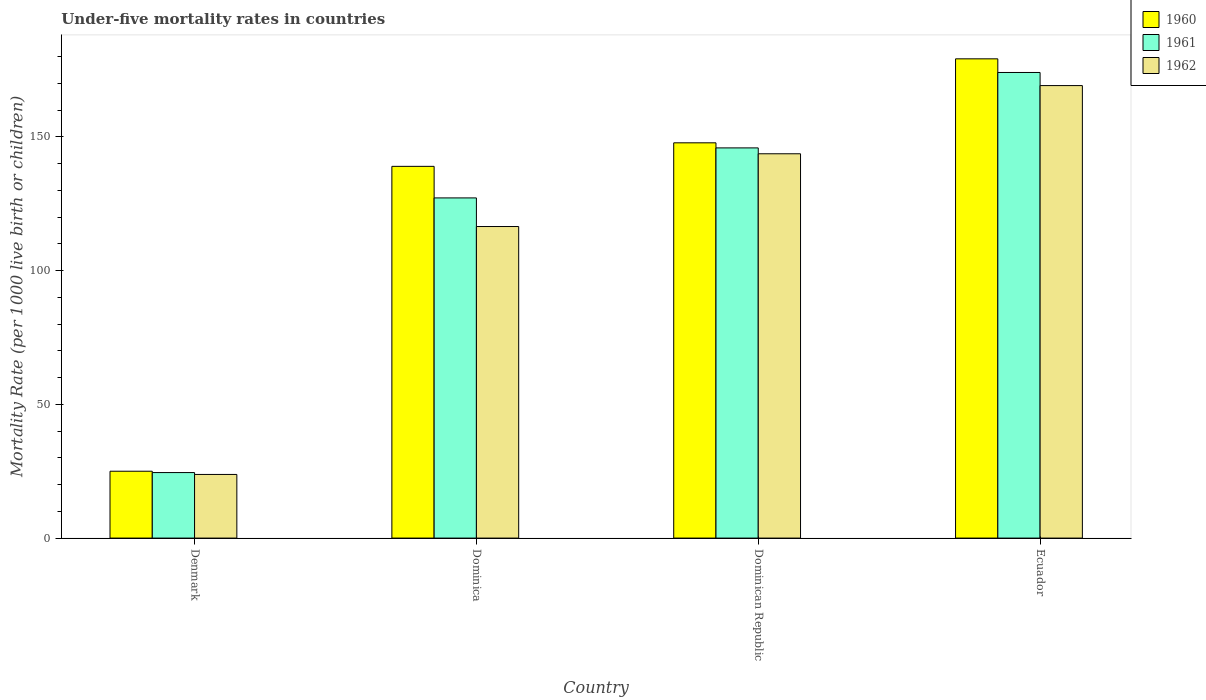How many different coloured bars are there?
Make the answer very short. 3. How many groups of bars are there?
Ensure brevity in your answer.  4. Are the number of bars per tick equal to the number of legend labels?
Your answer should be compact. Yes. Are the number of bars on each tick of the X-axis equal?
Your response must be concise. Yes. How many bars are there on the 3rd tick from the right?
Keep it short and to the point. 3. What is the label of the 1st group of bars from the left?
Offer a terse response. Denmark. What is the under-five mortality rate in 1962 in Dominica?
Keep it short and to the point. 116.5. Across all countries, what is the maximum under-five mortality rate in 1960?
Your answer should be compact. 179.2. Across all countries, what is the minimum under-five mortality rate in 1962?
Provide a short and direct response. 23.8. In which country was the under-five mortality rate in 1961 maximum?
Make the answer very short. Ecuador. What is the total under-five mortality rate in 1961 in the graph?
Offer a terse response. 471.7. What is the difference between the under-five mortality rate in 1961 in Dominica and that in Dominican Republic?
Make the answer very short. -18.7. What is the difference between the under-five mortality rate in 1962 in Denmark and the under-five mortality rate in 1960 in Dominica?
Provide a succinct answer. -115.2. What is the average under-five mortality rate in 1960 per country?
Give a very brief answer. 122.75. What is the difference between the under-five mortality rate of/in 1962 and under-five mortality rate of/in 1960 in Denmark?
Give a very brief answer. -1.2. What is the ratio of the under-five mortality rate in 1961 in Denmark to that in Ecuador?
Your answer should be compact. 0.14. Is the under-five mortality rate in 1960 in Dominica less than that in Ecuador?
Offer a terse response. Yes. Is the difference between the under-five mortality rate in 1962 in Denmark and Dominica greater than the difference between the under-five mortality rate in 1960 in Denmark and Dominica?
Ensure brevity in your answer.  Yes. What is the difference between the highest and the second highest under-five mortality rate in 1961?
Your response must be concise. -28.2. What is the difference between the highest and the lowest under-five mortality rate in 1960?
Your response must be concise. 154.2. In how many countries, is the under-five mortality rate in 1962 greater than the average under-five mortality rate in 1962 taken over all countries?
Your response must be concise. 3. What does the 3rd bar from the right in Dominican Republic represents?
Your response must be concise. 1960. Are all the bars in the graph horizontal?
Offer a terse response. No. How many countries are there in the graph?
Your response must be concise. 4. Are the values on the major ticks of Y-axis written in scientific E-notation?
Offer a terse response. No. Does the graph contain any zero values?
Ensure brevity in your answer.  No. Where does the legend appear in the graph?
Offer a very short reply. Top right. How many legend labels are there?
Ensure brevity in your answer.  3. How are the legend labels stacked?
Your answer should be compact. Vertical. What is the title of the graph?
Make the answer very short. Under-five mortality rates in countries. Does "1970" appear as one of the legend labels in the graph?
Keep it short and to the point. No. What is the label or title of the X-axis?
Offer a very short reply. Country. What is the label or title of the Y-axis?
Make the answer very short. Mortality Rate (per 1000 live birth or children). What is the Mortality Rate (per 1000 live birth or children) in 1961 in Denmark?
Your answer should be compact. 24.5. What is the Mortality Rate (per 1000 live birth or children) in 1962 in Denmark?
Your answer should be very brief. 23.8. What is the Mortality Rate (per 1000 live birth or children) in 1960 in Dominica?
Provide a short and direct response. 139. What is the Mortality Rate (per 1000 live birth or children) in 1961 in Dominica?
Your answer should be very brief. 127.2. What is the Mortality Rate (per 1000 live birth or children) of 1962 in Dominica?
Your answer should be compact. 116.5. What is the Mortality Rate (per 1000 live birth or children) in 1960 in Dominican Republic?
Your answer should be compact. 147.8. What is the Mortality Rate (per 1000 live birth or children) of 1961 in Dominican Republic?
Ensure brevity in your answer.  145.9. What is the Mortality Rate (per 1000 live birth or children) of 1962 in Dominican Republic?
Your answer should be very brief. 143.7. What is the Mortality Rate (per 1000 live birth or children) in 1960 in Ecuador?
Your answer should be very brief. 179.2. What is the Mortality Rate (per 1000 live birth or children) of 1961 in Ecuador?
Provide a succinct answer. 174.1. What is the Mortality Rate (per 1000 live birth or children) of 1962 in Ecuador?
Keep it short and to the point. 169.2. Across all countries, what is the maximum Mortality Rate (per 1000 live birth or children) of 1960?
Provide a short and direct response. 179.2. Across all countries, what is the maximum Mortality Rate (per 1000 live birth or children) of 1961?
Provide a succinct answer. 174.1. Across all countries, what is the maximum Mortality Rate (per 1000 live birth or children) in 1962?
Keep it short and to the point. 169.2. Across all countries, what is the minimum Mortality Rate (per 1000 live birth or children) of 1961?
Offer a terse response. 24.5. Across all countries, what is the minimum Mortality Rate (per 1000 live birth or children) in 1962?
Offer a very short reply. 23.8. What is the total Mortality Rate (per 1000 live birth or children) in 1960 in the graph?
Provide a succinct answer. 491. What is the total Mortality Rate (per 1000 live birth or children) of 1961 in the graph?
Your answer should be compact. 471.7. What is the total Mortality Rate (per 1000 live birth or children) of 1962 in the graph?
Give a very brief answer. 453.2. What is the difference between the Mortality Rate (per 1000 live birth or children) of 1960 in Denmark and that in Dominica?
Keep it short and to the point. -114. What is the difference between the Mortality Rate (per 1000 live birth or children) of 1961 in Denmark and that in Dominica?
Offer a terse response. -102.7. What is the difference between the Mortality Rate (per 1000 live birth or children) in 1962 in Denmark and that in Dominica?
Keep it short and to the point. -92.7. What is the difference between the Mortality Rate (per 1000 live birth or children) of 1960 in Denmark and that in Dominican Republic?
Your answer should be very brief. -122.8. What is the difference between the Mortality Rate (per 1000 live birth or children) in 1961 in Denmark and that in Dominican Republic?
Offer a terse response. -121.4. What is the difference between the Mortality Rate (per 1000 live birth or children) in 1962 in Denmark and that in Dominican Republic?
Keep it short and to the point. -119.9. What is the difference between the Mortality Rate (per 1000 live birth or children) in 1960 in Denmark and that in Ecuador?
Make the answer very short. -154.2. What is the difference between the Mortality Rate (per 1000 live birth or children) in 1961 in Denmark and that in Ecuador?
Your response must be concise. -149.6. What is the difference between the Mortality Rate (per 1000 live birth or children) of 1962 in Denmark and that in Ecuador?
Provide a short and direct response. -145.4. What is the difference between the Mortality Rate (per 1000 live birth or children) of 1961 in Dominica and that in Dominican Republic?
Give a very brief answer. -18.7. What is the difference between the Mortality Rate (per 1000 live birth or children) of 1962 in Dominica and that in Dominican Republic?
Provide a short and direct response. -27.2. What is the difference between the Mortality Rate (per 1000 live birth or children) of 1960 in Dominica and that in Ecuador?
Keep it short and to the point. -40.2. What is the difference between the Mortality Rate (per 1000 live birth or children) in 1961 in Dominica and that in Ecuador?
Ensure brevity in your answer.  -46.9. What is the difference between the Mortality Rate (per 1000 live birth or children) of 1962 in Dominica and that in Ecuador?
Your response must be concise. -52.7. What is the difference between the Mortality Rate (per 1000 live birth or children) of 1960 in Dominican Republic and that in Ecuador?
Provide a short and direct response. -31.4. What is the difference between the Mortality Rate (per 1000 live birth or children) in 1961 in Dominican Republic and that in Ecuador?
Keep it short and to the point. -28.2. What is the difference between the Mortality Rate (per 1000 live birth or children) of 1962 in Dominican Republic and that in Ecuador?
Offer a very short reply. -25.5. What is the difference between the Mortality Rate (per 1000 live birth or children) in 1960 in Denmark and the Mortality Rate (per 1000 live birth or children) in 1961 in Dominica?
Give a very brief answer. -102.2. What is the difference between the Mortality Rate (per 1000 live birth or children) in 1960 in Denmark and the Mortality Rate (per 1000 live birth or children) in 1962 in Dominica?
Your response must be concise. -91.5. What is the difference between the Mortality Rate (per 1000 live birth or children) of 1961 in Denmark and the Mortality Rate (per 1000 live birth or children) of 1962 in Dominica?
Keep it short and to the point. -92. What is the difference between the Mortality Rate (per 1000 live birth or children) in 1960 in Denmark and the Mortality Rate (per 1000 live birth or children) in 1961 in Dominican Republic?
Ensure brevity in your answer.  -120.9. What is the difference between the Mortality Rate (per 1000 live birth or children) of 1960 in Denmark and the Mortality Rate (per 1000 live birth or children) of 1962 in Dominican Republic?
Give a very brief answer. -118.7. What is the difference between the Mortality Rate (per 1000 live birth or children) of 1961 in Denmark and the Mortality Rate (per 1000 live birth or children) of 1962 in Dominican Republic?
Make the answer very short. -119.2. What is the difference between the Mortality Rate (per 1000 live birth or children) in 1960 in Denmark and the Mortality Rate (per 1000 live birth or children) in 1961 in Ecuador?
Keep it short and to the point. -149.1. What is the difference between the Mortality Rate (per 1000 live birth or children) in 1960 in Denmark and the Mortality Rate (per 1000 live birth or children) in 1962 in Ecuador?
Offer a very short reply. -144.2. What is the difference between the Mortality Rate (per 1000 live birth or children) in 1961 in Denmark and the Mortality Rate (per 1000 live birth or children) in 1962 in Ecuador?
Offer a terse response. -144.7. What is the difference between the Mortality Rate (per 1000 live birth or children) in 1960 in Dominica and the Mortality Rate (per 1000 live birth or children) in 1961 in Dominican Republic?
Provide a short and direct response. -6.9. What is the difference between the Mortality Rate (per 1000 live birth or children) of 1960 in Dominica and the Mortality Rate (per 1000 live birth or children) of 1962 in Dominican Republic?
Your response must be concise. -4.7. What is the difference between the Mortality Rate (per 1000 live birth or children) of 1961 in Dominica and the Mortality Rate (per 1000 live birth or children) of 1962 in Dominican Republic?
Keep it short and to the point. -16.5. What is the difference between the Mortality Rate (per 1000 live birth or children) of 1960 in Dominica and the Mortality Rate (per 1000 live birth or children) of 1961 in Ecuador?
Offer a very short reply. -35.1. What is the difference between the Mortality Rate (per 1000 live birth or children) in 1960 in Dominica and the Mortality Rate (per 1000 live birth or children) in 1962 in Ecuador?
Provide a short and direct response. -30.2. What is the difference between the Mortality Rate (per 1000 live birth or children) in 1961 in Dominica and the Mortality Rate (per 1000 live birth or children) in 1962 in Ecuador?
Provide a succinct answer. -42. What is the difference between the Mortality Rate (per 1000 live birth or children) of 1960 in Dominican Republic and the Mortality Rate (per 1000 live birth or children) of 1961 in Ecuador?
Ensure brevity in your answer.  -26.3. What is the difference between the Mortality Rate (per 1000 live birth or children) of 1960 in Dominican Republic and the Mortality Rate (per 1000 live birth or children) of 1962 in Ecuador?
Offer a terse response. -21.4. What is the difference between the Mortality Rate (per 1000 live birth or children) in 1961 in Dominican Republic and the Mortality Rate (per 1000 live birth or children) in 1962 in Ecuador?
Your response must be concise. -23.3. What is the average Mortality Rate (per 1000 live birth or children) of 1960 per country?
Your answer should be compact. 122.75. What is the average Mortality Rate (per 1000 live birth or children) of 1961 per country?
Your response must be concise. 117.92. What is the average Mortality Rate (per 1000 live birth or children) of 1962 per country?
Your response must be concise. 113.3. What is the difference between the Mortality Rate (per 1000 live birth or children) of 1960 and Mortality Rate (per 1000 live birth or children) of 1961 in Denmark?
Make the answer very short. 0.5. What is the difference between the Mortality Rate (per 1000 live birth or children) of 1960 and Mortality Rate (per 1000 live birth or children) of 1962 in Denmark?
Your response must be concise. 1.2. What is the difference between the Mortality Rate (per 1000 live birth or children) in 1961 and Mortality Rate (per 1000 live birth or children) in 1962 in Denmark?
Make the answer very short. 0.7. What is the difference between the Mortality Rate (per 1000 live birth or children) in 1961 and Mortality Rate (per 1000 live birth or children) in 1962 in Dominica?
Ensure brevity in your answer.  10.7. What is the difference between the Mortality Rate (per 1000 live birth or children) of 1960 and Mortality Rate (per 1000 live birth or children) of 1961 in Dominican Republic?
Ensure brevity in your answer.  1.9. What is the difference between the Mortality Rate (per 1000 live birth or children) in 1960 and Mortality Rate (per 1000 live birth or children) in 1962 in Dominican Republic?
Your answer should be very brief. 4.1. What is the difference between the Mortality Rate (per 1000 live birth or children) in 1960 and Mortality Rate (per 1000 live birth or children) in 1961 in Ecuador?
Offer a terse response. 5.1. What is the ratio of the Mortality Rate (per 1000 live birth or children) in 1960 in Denmark to that in Dominica?
Your response must be concise. 0.18. What is the ratio of the Mortality Rate (per 1000 live birth or children) in 1961 in Denmark to that in Dominica?
Your answer should be compact. 0.19. What is the ratio of the Mortality Rate (per 1000 live birth or children) of 1962 in Denmark to that in Dominica?
Provide a short and direct response. 0.2. What is the ratio of the Mortality Rate (per 1000 live birth or children) of 1960 in Denmark to that in Dominican Republic?
Give a very brief answer. 0.17. What is the ratio of the Mortality Rate (per 1000 live birth or children) of 1961 in Denmark to that in Dominican Republic?
Give a very brief answer. 0.17. What is the ratio of the Mortality Rate (per 1000 live birth or children) in 1962 in Denmark to that in Dominican Republic?
Provide a succinct answer. 0.17. What is the ratio of the Mortality Rate (per 1000 live birth or children) in 1960 in Denmark to that in Ecuador?
Give a very brief answer. 0.14. What is the ratio of the Mortality Rate (per 1000 live birth or children) of 1961 in Denmark to that in Ecuador?
Offer a terse response. 0.14. What is the ratio of the Mortality Rate (per 1000 live birth or children) in 1962 in Denmark to that in Ecuador?
Make the answer very short. 0.14. What is the ratio of the Mortality Rate (per 1000 live birth or children) in 1960 in Dominica to that in Dominican Republic?
Your answer should be compact. 0.94. What is the ratio of the Mortality Rate (per 1000 live birth or children) of 1961 in Dominica to that in Dominican Republic?
Your response must be concise. 0.87. What is the ratio of the Mortality Rate (per 1000 live birth or children) in 1962 in Dominica to that in Dominican Republic?
Your response must be concise. 0.81. What is the ratio of the Mortality Rate (per 1000 live birth or children) of 1960 in Dominica to that in Ecuador?
Provide a succinct answer. 0.78. What is the ratio of the Mortality Rate (per 1000 live birth or children) in 1961 in Dominica to that in Ecuador?
Your answer should be compact. 0.73. What is the ratio of the Mortality Rate (per 1000 live birth or children) in 1962 in Dominica to that in Ecuador?
Offer a terse response. 0.69. What is the ratio of the Mortality Rate (per 1000 live birth or children) of 1960 in Dominican Republic to that in Ecuador?
Ensure brevity in your answer.  0.82. What is the ratio of the Mortality Rate (per 1000 live birth or children) in 1961 in Dominican Republic to that in Ecuador?
Provide a short and direct response. 0.84. What is the ratio of the Mortality Rate (per 1000 live birth or children) in 1962 in Dominican Republic to that in Ecuador?
Ensure brevity in your answer.  0.85. What is the difference between the highest and the second highest Mortality Rate (per 1000 live birth or children) in 1960?
Make the answer very short. 31.4. What is the difference between the highest and the second highest Mortality Rate (per 1000 live birth or children) in 1961?
Ensure brevity in your answer.  28.2. What is the difference between the highest and the second highest Mortality Rate (per 1000 live birth or children) of 1962?
Offer a terse response. 25.5. What is the difference between the highest and the lowest Mortality Rate (per 1000 live birth or children) of 1960?
Ensure brevity in your answer.  154.2. What is the difference between the highest and the lowest Mortality Rate (per 1000 live birth or children) of 1961?
Your response must be concise. 149.6. What is the difference between the highest and the lowest Mortality Rate (per 1000 live birth or children) of 1962?
Keep it short and to the point. 145.4. 